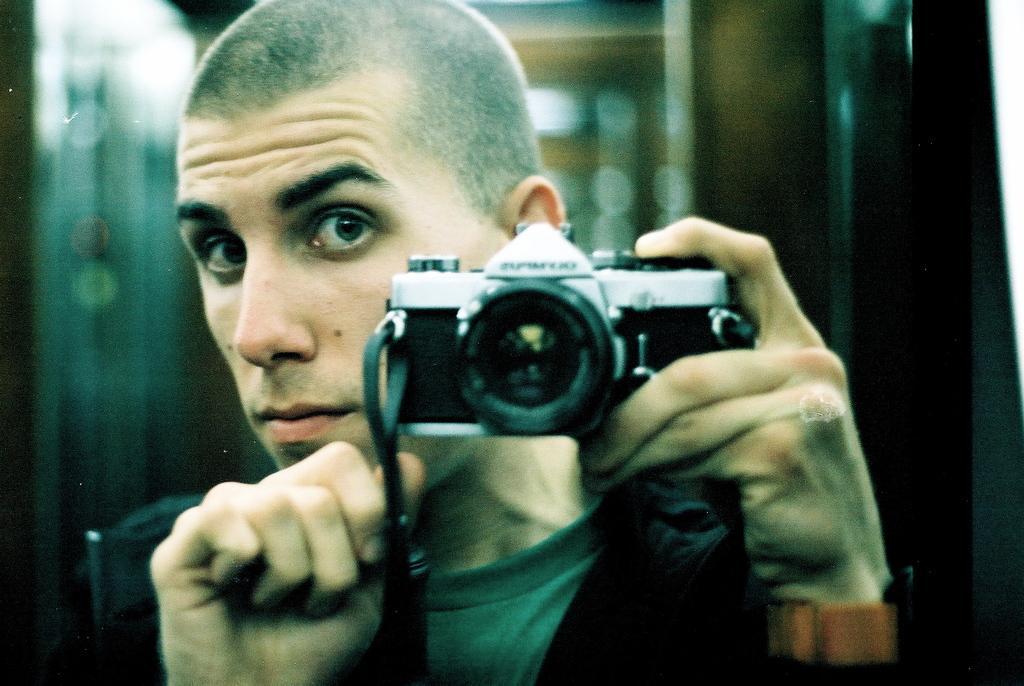Describe this image in one or two sentences. This image is taken indoors. In this image the background is a little blurred. In the middle of the image there is a man and he is holding a camera in his hand. 